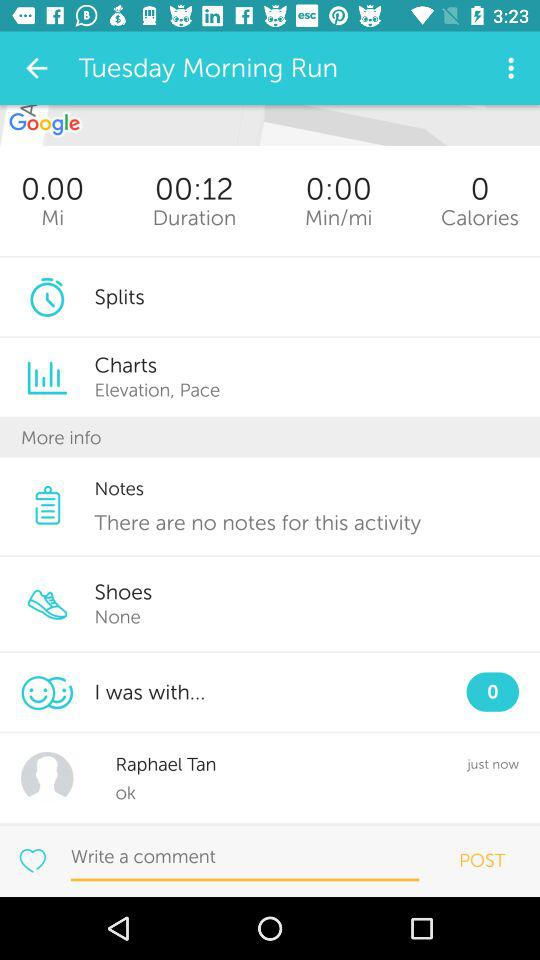What is the duration mentioned in "Tuesday Morning Run"? The duration mentioned in "Tuesday Morning Run" is 12 seconds. 